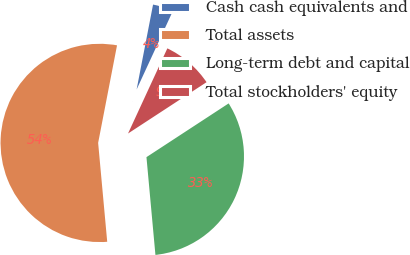<chart> <loc_0><loc_0><loc_500><loc_500><pie_chart><fcel>Cash cash equivalents and<fcel>Total assets<fcel>Long-term debt and capital<fcel>Total stockholders' equity<nl><fcel>3.84%<fcel>54.5%<fcel>32.76%<fcel>8.9%<nl></chart> 